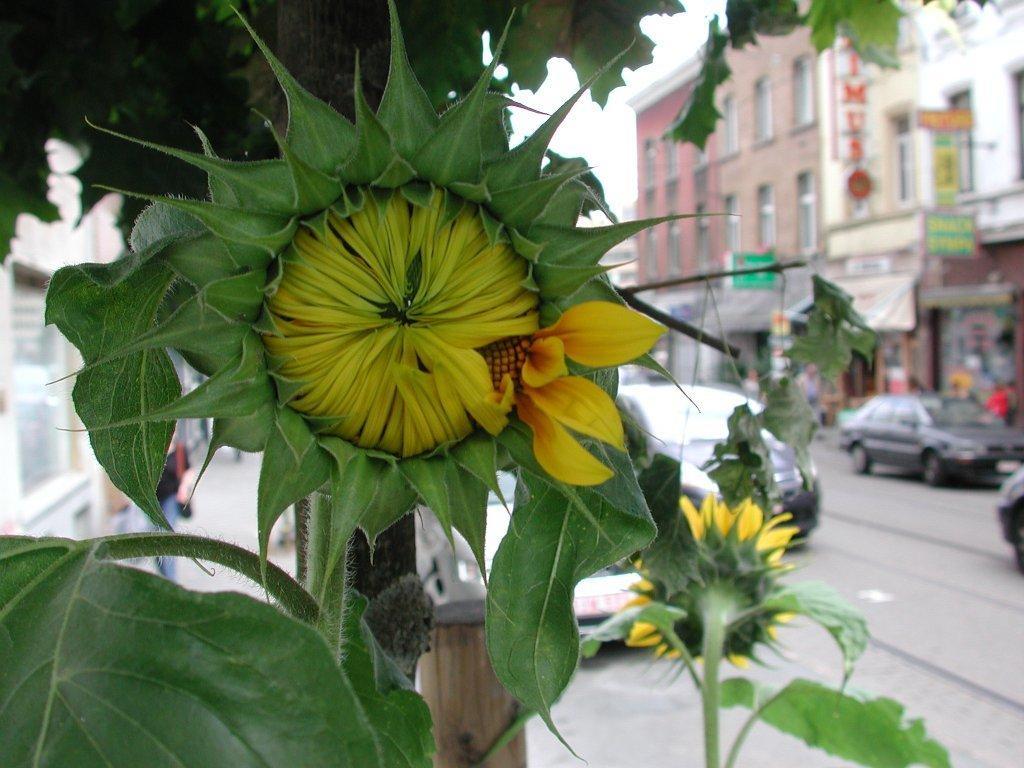In one or two sentences, can you explain what this image depicts? In front of the image there are flowers and leaves, beside the flowers there are cars passing on the road, beside the road there are shops beneath the buildings and there are a few people walking on the pavement. 